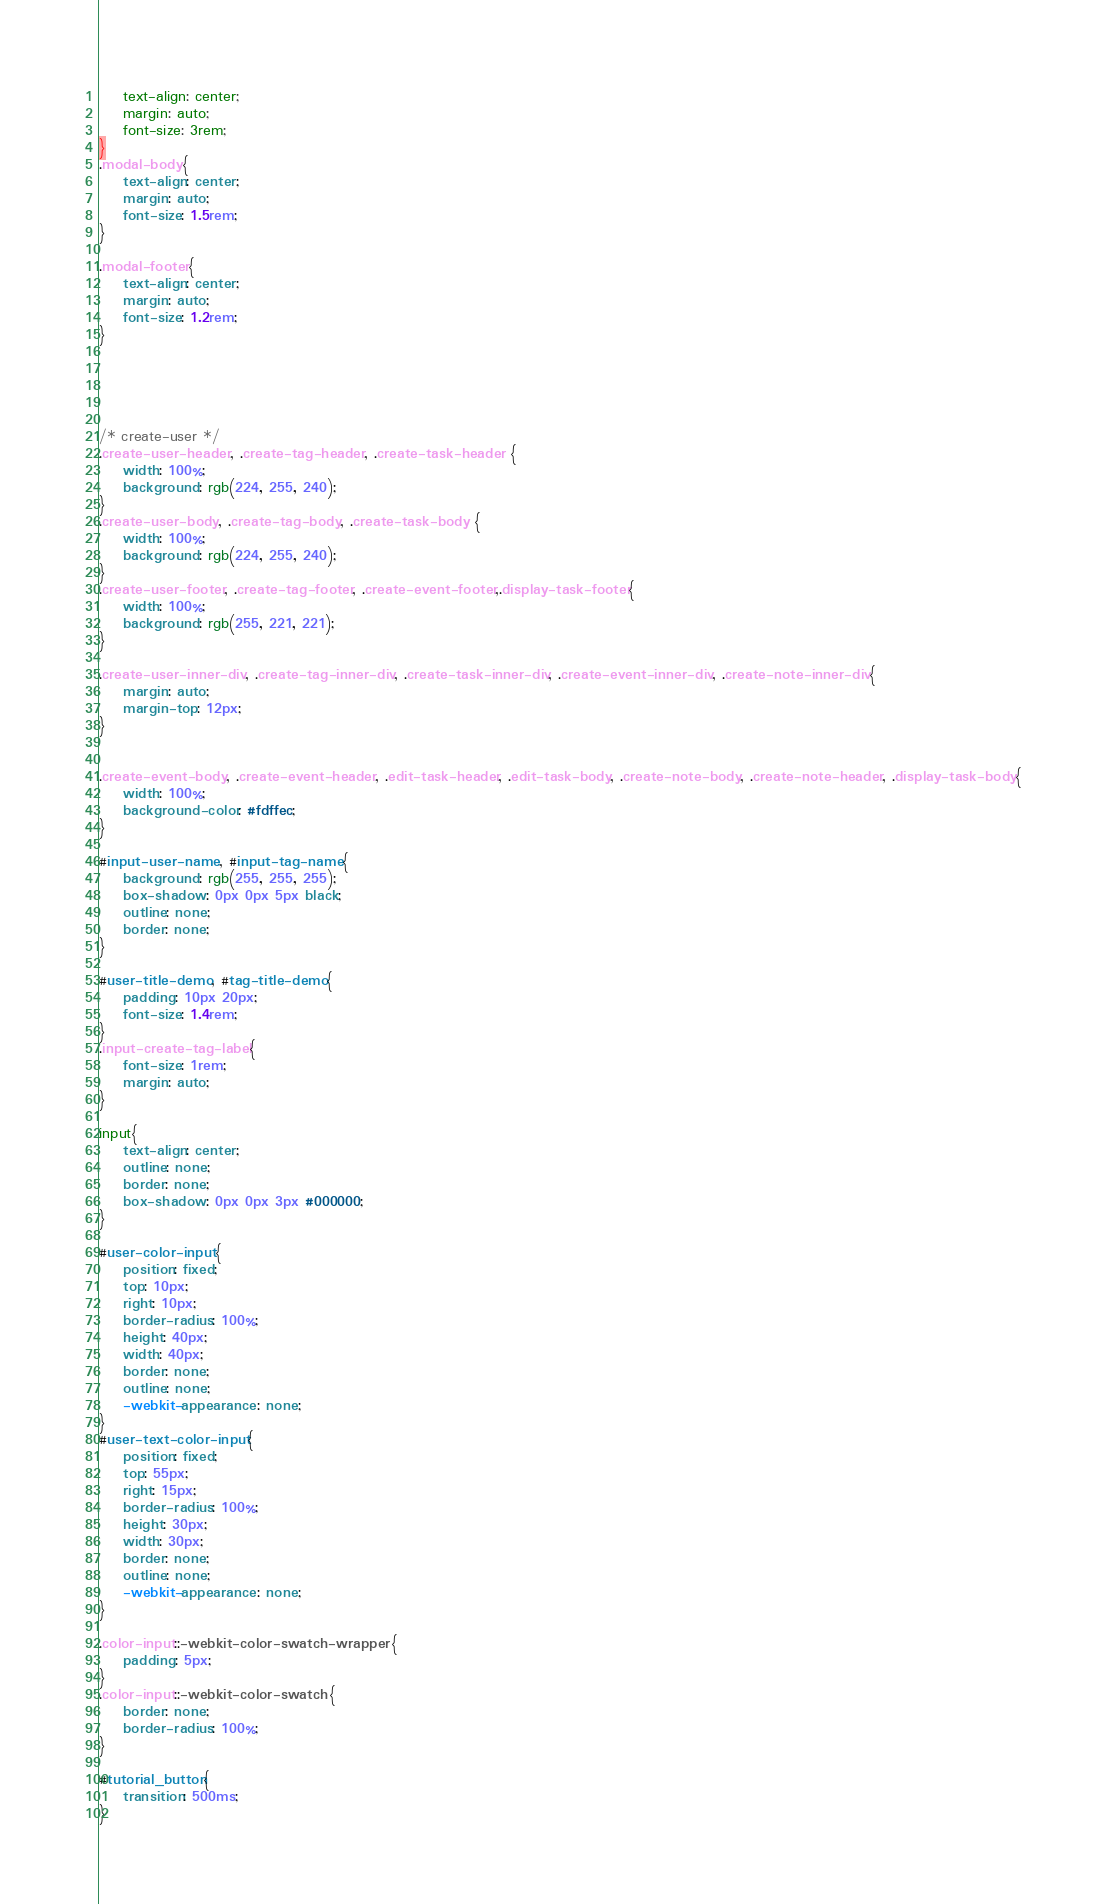Convert code to text. <code><loc_0><loc_0><loc_500><loc_500><_CSS_>    text-align: center;
    margin: auto;
    font-size: 3rem;
}
.modal-body{
    text-align: center;
    margin: auto;
    font-size: 1.5rem;
}

.modal-footer{
    text-align: center;
    margin: auto;
    font-size: 1.2rem;
}





/* create-user */
.create-user-header, .create-tag-header, .create-task-header {
    width: 100%;
    background: rgb(224, 255, 240);
}
.create-user-body, .create-tag-body, .create-task-body {
    width: 100%;
    background: rgb(224, 255, 240);
}
.create-user-footer, .create-tag-footer, .create-event-footer,.display-task-footer{
    width: 100%;
    background: rgb(255, 221, 221);    
}

.create-user-inner-div, .create-tag-inner-div, .create-task-inner-div, .create-event-inner-div, .create-note-inner-div{
    margin: auto;
    margin-top: 12px;
}


.create-event-body, .create-event-header, .edit-task-header, .edit-task-body, .create-note-body, .create-note-header, .display-task-body{
    width: 100%;
    background-color: #fdffec;
}

#input-user-name, #input-tag-name{
    background: rgb(255, 255, 255);
    box-shadow: 0px 0px 5px black;
    outline: none;
    border: none;
}

#user-title-demo, #tag-title-demo{
    padding: 10px 20px;
    font-size: 1.4rem;
}
.input-create-tag-label{
    font-size: 1rem;
    margin: auto;
}

input{
    text-align: center;
    outline: none;
    border: none;
    box-shadow: 0px 0px 3px #000000;
}

#user-color-input{
    position: fixed;
    top: 10px;
    right: 10px;
    border-radius: 100%;
    height: 40px;
    width: 40px;
    border: none;
    outline: none;
    -webkit-appearance: none;
}
#user-text-color-input{
    position: fixed;
    top: 55px;
    right: 15px;
    border-radius: 100%;
    height: 30px;
    width: 30px;
    border: none;
    outline: none;
    -webkit-appearance: none;
}

.color-input::-webkit-color-swatch-wrapper {
    padding: 5px;	
}
.color-input::-webkit-color-swatch {    
    border: none;
    border-radius: 100%;
}

#tutorial_button{
    transition: 500ms;
}</code> 